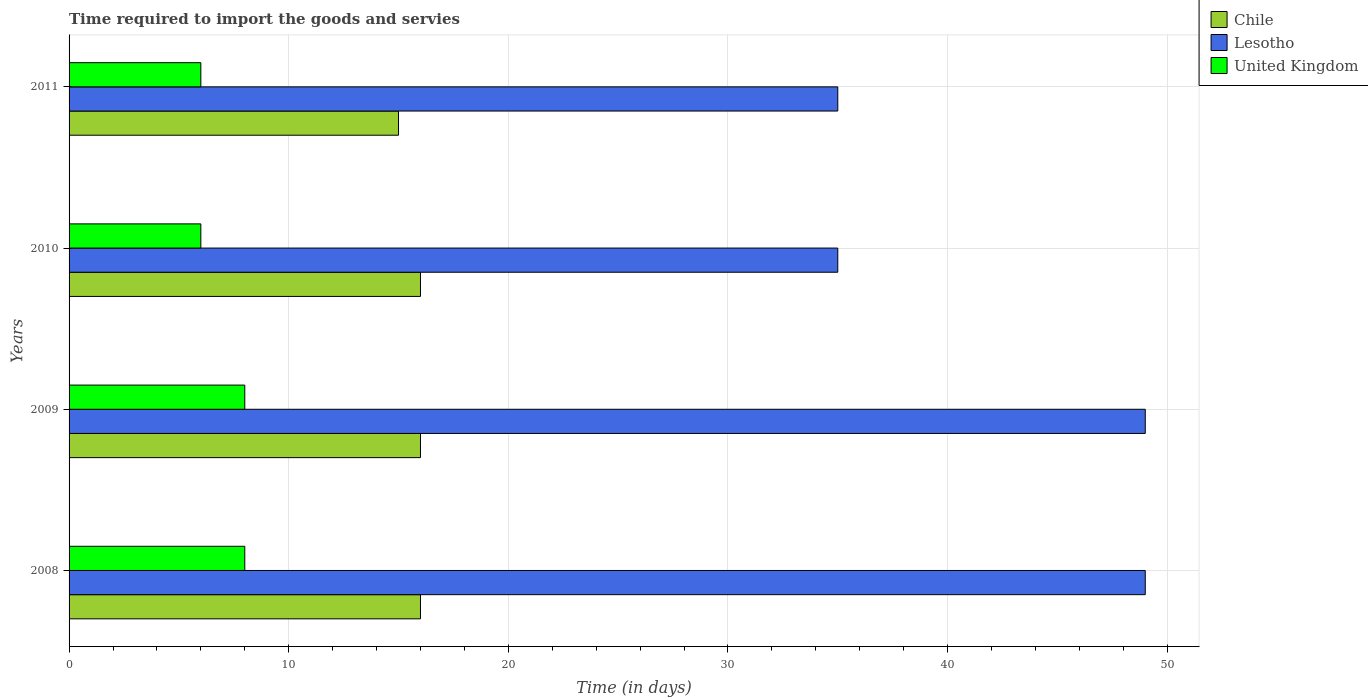Are the number of bars on each tick of the Y-axis equal?
Provide a succinct answer. Yes. How many bars are there on the 4th tick from the bottom?
Provide a succinct answer. 3. What is the number of days required to import the goods and services in Lesotho in 2011?
Provide a succinct answer. 35. Across all years, what is the maximum number of days required to import the goods and services in Lesotho?
Keep it short and to the point. 49. Across all years, what is the minimum number of days required to import the goods and services in Chile?
Make the answer very short. 15. In which year was the number of days required to import the goods and services in United Kingdom maximum?
Provide a short and direct response. 2008. What is the total number of days required to import the goods and services in Chile in the graph?
Provide a succinct answer. 63. What is the difference between the number of days required to import the goods and services in Chile in 2010 and that in 2011?
Your response must be concise. 1. What is the difference between the number of days required to import the goods and services in Chile in 2009 and the number of days required to import the goods and services in Lesotho in 2008?
Provide a short and direct response. -33. What is the average number of days required to import the goods and services in Chile per year?
Provide a succinct answer. 15.75. In the year 2010, what is the difference between the number of days required to import the goods and services in Lesotho and number of days required to import the goods and services in United Kingdom?
Make the answer very short. 29. What is the difference between the highest and the second highest number of days required to import the goods and services in Lesotho?
Your answer should be very brief. 0. What is the difference between the highest and the lowest number of days required to import the goods and services in United Kingdom?
Give a very brief answer. 2. Is the sum of the number of days required to import the goods and services in Lesotho in 2008 and 2010 greater than the maximum number of days required to import the goods and services in Chile across all years?
Your answer should be very brief. Yes. What does the 2nd bar from the top in 2008 represents?
Your answer should be compact. Lesotho. What does the 1st bar from the bottom in 2009 represents?
Your response must be concise. Chile. How many bars are there?
Offer a terse response. 12. Does the graph contain any zero values?
Provide a succinct answer. No. What is the title of the graph?
Ensure brevity in your answer.  Time required to import the goods and servies. What is the label or title of the X-axis?
Ensure brevity in your answer.  Time (in days). What is the label or title of the Y-axis?
Offer a very short reply. Years. What is the Time (in days) of United Kingdom in 2008?
Give a very brief answer. 8. What is the Time (in days) of United Kingdom in 2009?
Provide a succinct answer. 8. What is the Time (in days) of Chile in 2011?
Keep it short and to the point. 15. What is the Time (in days) of United Kingdom in 2011?
Offer a very short reply. 6. Across all years, what is the maximum Time (in days) in Chile?
Offer a very short reply. 16. Across all years, what is the maximum Time (in days) in Lesotho?
Offer a very short reply. 49. Across all years, what is the maximum Time (in days) in United Kingdom?
Make the answer very short. 8. Across all years, what is the minimum Time (in days) of Lesotho?
Your answer should be compact. 35. What is the total Time (in days) of Lesotho in the graph?
Give a very brief answer. 168. What is the difference between the Time (in days) in Chile in 2008 and that in 2010?
Your answer should be very brief. 0. What is the difference between the Time (in days) of United Kingdom in 2008 and that in 2010?
Make the answer very short. 2. What is the difference between the Time (in days) in Chile in 2008 and that in 2011?
Provide a succinct answer. 1. What is the difference between the Time (in days) of Chile in 2009 and that in 2010?
Your answer should be compact. 0. What is the difference between the Time (in days) of United Kingdom in 2009 and that in 2010?
Your answer should be very brief. 2. What is the difference between the Time (in days) of Chile in 2009 and that in 2011?
Your answer should be very brief. 1. What is the difference between the Time (in days) in Lesotho in 2009 and that in 2011?
Your answer should be compact. 14. What is the difference between the Time (in days) in United Kingdom in 2009 and that in 2011?
Your answer should be compact. 2. What is the difference between the Time (in days) in Chile in 2008 and the Time (in days) in Lesotho in 2009?
Make the answer very short. -33. What is the difference between the Time (in days) of Lesotho in 2008 and the Time (in days) of United Kingdom in 2009?
Provide a short and direct response. 41. What is the difference between the Time (in days) of Chile in 2008 and the Time (in days) of United Kingdom in 2010?
Your answer should be compact. 10. What is the difference between the Time (in days) in Chile in 2008 and the Time (in days) in Lesotho in 2011?
Your response must be concise. -19. What is the difference between the Time (in days) of Lesotho in 2008 and the Time (in days) of United Kingdom in 2011?
Ensure brevity in your answer.  43. What is the difference between the Time (in days) in Chile in 2009 and the Time (in days) in Lesotho in 2010?
Offer a very short reply. -19. What is the difference between the Time (in days) of Chile in 2009 and the Time (in days) of Lesotho in 2011?
Ensure brevity in your answer.  -19. What is the difference between the Time (in days) of Chile in 2009 and the Time (in days) of United Kingdom in 2011?
Your answer should be very brief. 10. What is the difference between the Time (in days) in Lesotho in 2009 and the Time (in days) in United Kingdom in 2011?
Provide a short and direct response. 43. What is the difference between the Time (in days) of Chile in 2010 and the Time (in days) of United Kingdom in 2011?
Offer a terse response. 10. What is the average Time (in days) of Chile per year?
Keep it short and to the point. 15.75. What is the average Time (in days) in Lesotho per year?
Offer a terse response. 42. What is the average Time (in days) in United Kingdom per year?
Your answer should be compact. 7. In the year 2008, what is the difference between the Time (in days) in Chile and Time (in days) in Lesotho?
Keep it short and to the point. -33. In the year 2008, what is the difference between the Time (in days) of Lesotho and Time (in days) of United Kingdom?
Make the answer very short. 41. In the year 2009, what is the difference between the Time (in days) of Chile and Time (in days) of Lesotho?
Your answer should be compact. -33. In the year 2010, what is the difference between the Time (in days) of Chile and Time (in days) of Lesotho?
Offer a terse response. -19. In the year 2011, what is the difference between the Time (in days) of Lesotho and Time (in days) of United Kingdom?
Your answer should be compact. 29. What is the ratio of the Time (in days) of Chile in 2008 to that in 2009?
Your response must be concise. 1. What is the ratio of the Time (in days) of Lesotho in 2008 to that in 2009?
Offer a very short reply. 1. What is the ratio of the Time (in days) in United Kingdom in 2008 to that in 2009?
Your response must be concise. 1. What is the ratio of the Time (in days) in United Kingdom in 2008 to that in 2010?
Give a very brief answer. 1.33. What is the ratio of the Time (in days) in Chile in 2008 to that in 2011?
Your answer should be very brief. 1.07. What is the ratio of the Time (in days) of Lesotho in 2008 to that in 2011?
Offer a terse response. 1.4. What is the ratio of the Time (in days) of United Kingdom in 2008 to that in 2011?
Your response must be concise. 1.33. What is the ratio of the Time (in days) of Lesotho in 2009 to that in 2010?
Your answer should be compact. 1.4. What is the ratio of the Time (in days) of Chile in 2009 to that in 2011?
Offer a terse response. 1.07. What is the ratio of the Time (in days) in Lesotho in 2009 to that in 2011?
Make the answer very short. 1.4. What is the ratio of the Time (in days) in Chile in 2010 to that in 2011?
Make the answer very short. 1.07. What is the ratio of the Time (in days) in Lesotho in 2010 to that in 2011?
Make the answer very short. 1. What is the ratio of the Time (in days) in United Kingdom in 2010 to that in 2011?
Make the answer very short. 1. What is the difference between the highest and the second highest Time (in days) in Chile?
Ensure brevity in your answer.  0. What is the difference between the highest and the second highest Time (in days) in United Kingdom?
Provide a short and direct response. 0. What is the difference between the highest and the lowest Time (in days) in Chile?
Make the answer very short. 1. 